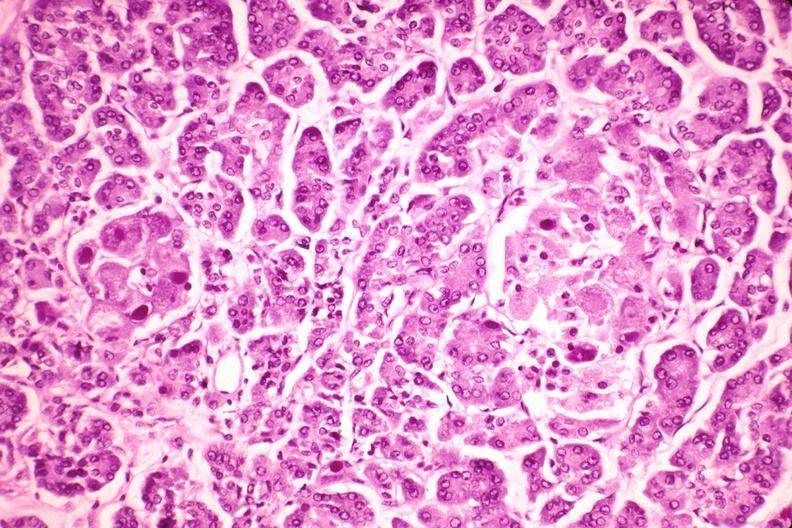where is this?
Answer the question using a single word or phrase. Pancreas 